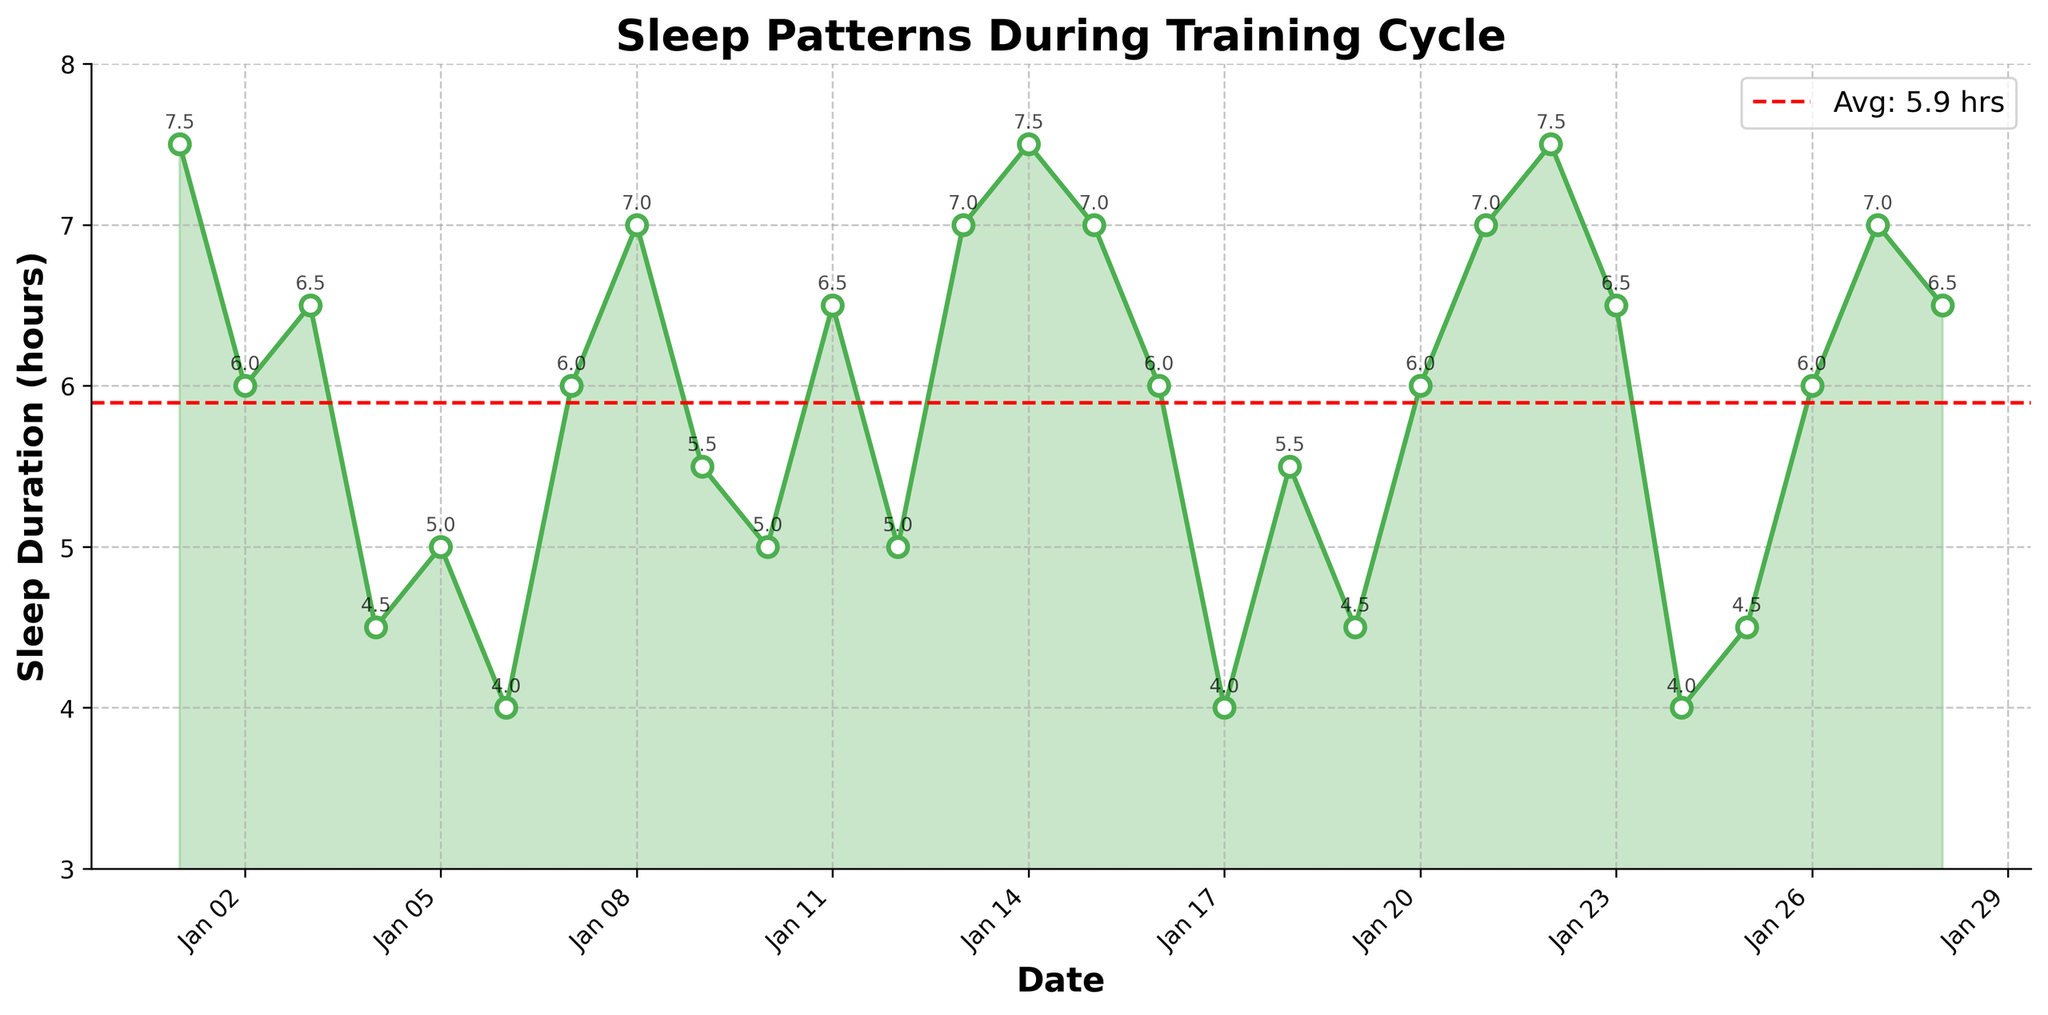What is the title of the plot? The title is usually displayed at the top center of the plot. This particular plot title is 'Sleep Patterns During Training Cycle'.
Answer: Sleep Patterns During Training Cycle What is the duration for the highest sleep logged? Look at the highest point on the vertical axis (Y-axis) which represents the 'Sleep (hours)'. The highest value is 7.5 hours, occurring on January 1, January 14, and January 22.
Answer: January 1, January 14, January 22 What is the average sleep duration? The average sleep duration is usually indicated by a horizontal line in the plot with a label. Here, the red dashed line shows the average duration. You can also calculate it by summing all sleep hours and dividing by the number of days.
Answer: Approximately 6.0 hours On which date did the lowest sleep duration occur? Find the lowest point on the graph along the Y-axis, which is 4.0 hours. This value occurs on January 6, January 17, and January 24.
Answer: January 6, January 17, January 24 What was the sleep duration on January 10? Locate January 10 on the X-axis and check the corresponding point's value on the Y-axis. The value is 5.0 hours.
Answer: 5.0 hours How many data points are plotted in the figure? Count the total number of markers or data points visible in the plot. Each point indicates a daily sleep duration entry. The data contains one value for each day from January 1 to January 28.
Answer: 28 Is there a date with exactly 5 hours of sleep? If yes, when? Scan the plot to find a point on the graph where the Y-value is exactly 5 hours. This happens on January 5, January 10, and January 12.
Answer: January 5, January 10, January 12 What is the difference in sleep duration between January 4 and January 5? Find the sleep durations for January 4 (4.5 hours) and January 5 (5.0 hours). The difference is 5.0 - 4.5 = 0.5 hours.
Answer: 0.5 hours What trend do you observe in the sleep pattern between January 22 and January 24? Look at the slope of the line between January 22 and January 24. On January 22 the sleep duration is 7.5 hours and it drops to 4.0 hours by January 24, showing a significant decline.
Answer: Significant decline Between January 11 and January 20, how many days was the sleep duration 6 hours or more? Identify the number of days in the range where the Y-value is 6 hours or more. These values appear on January 13 (7.0), January 14 (7.5), January 15 (7.0), and January 20 (6.0), giving a total of 4 days.
Answer: 4 days 